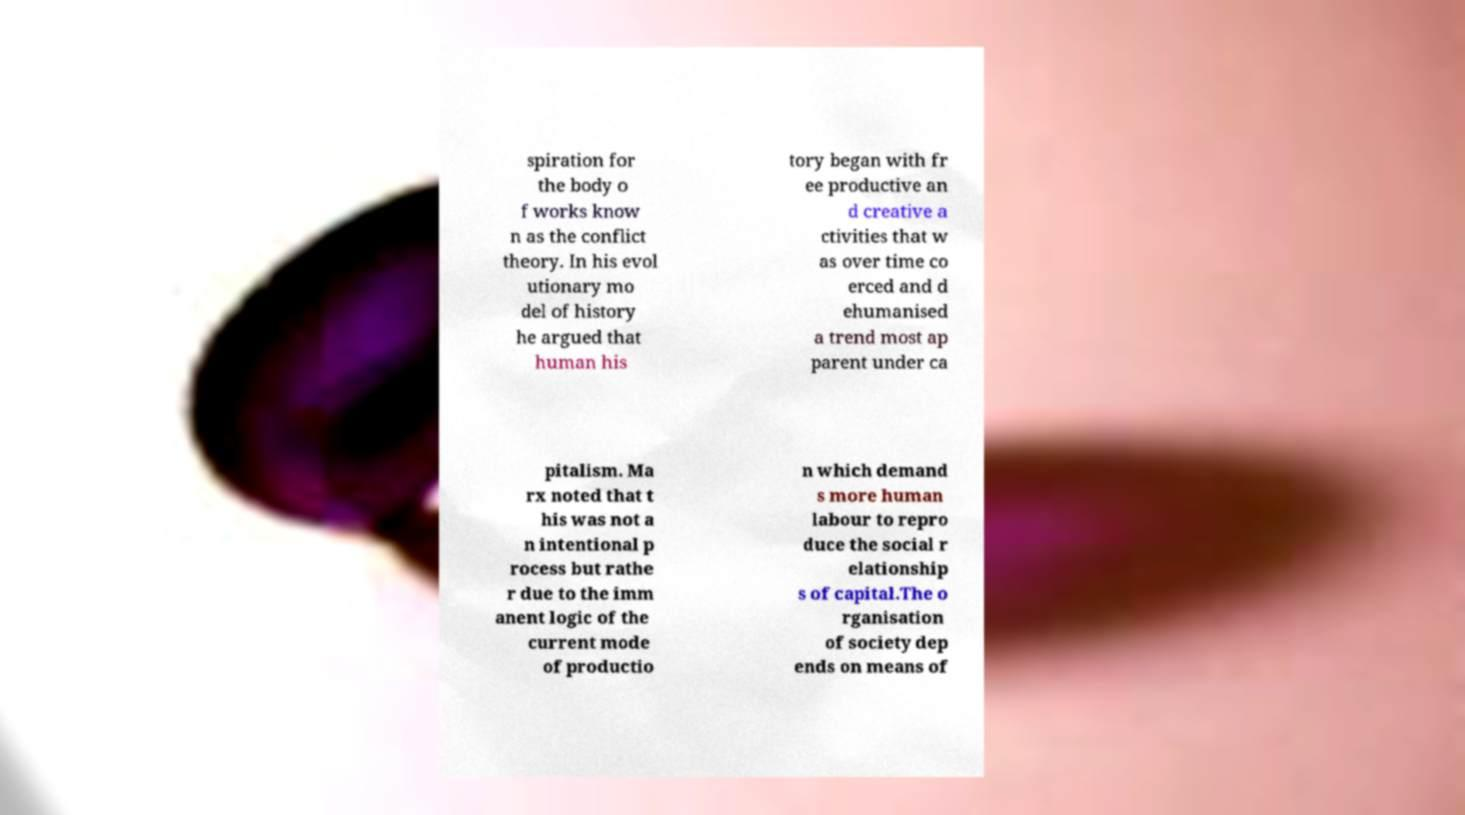What messages or text are displayed in this image? I need them in a readable, typed format. spiration for the body o f works know n as the conflict theory. In his evol utionary mo del of history he argued that human his tory began with fr ee productive an d creative a ctivities that w as over time co erced and d ehumanised a trend most ap parent under ca pitalism. Ma rx noted that t his was not a n intentional p rocess but rathe r due to the imm anent logic of the current mode of productio n which demand s more human labour to repro duce the social r elationship s of capital.The o rganisation of society dep ends on means of 